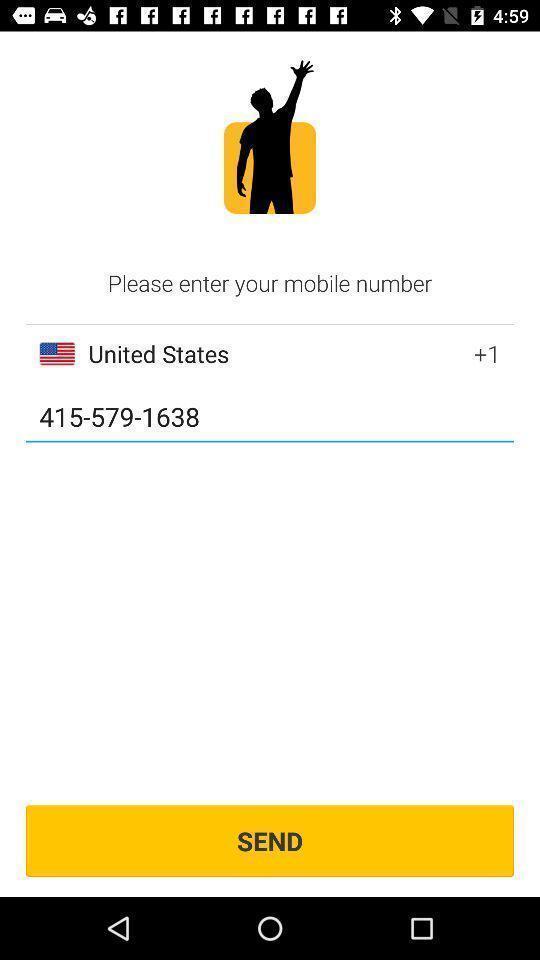Describe the key features of this screenshot. Window displaying a traveller app. 